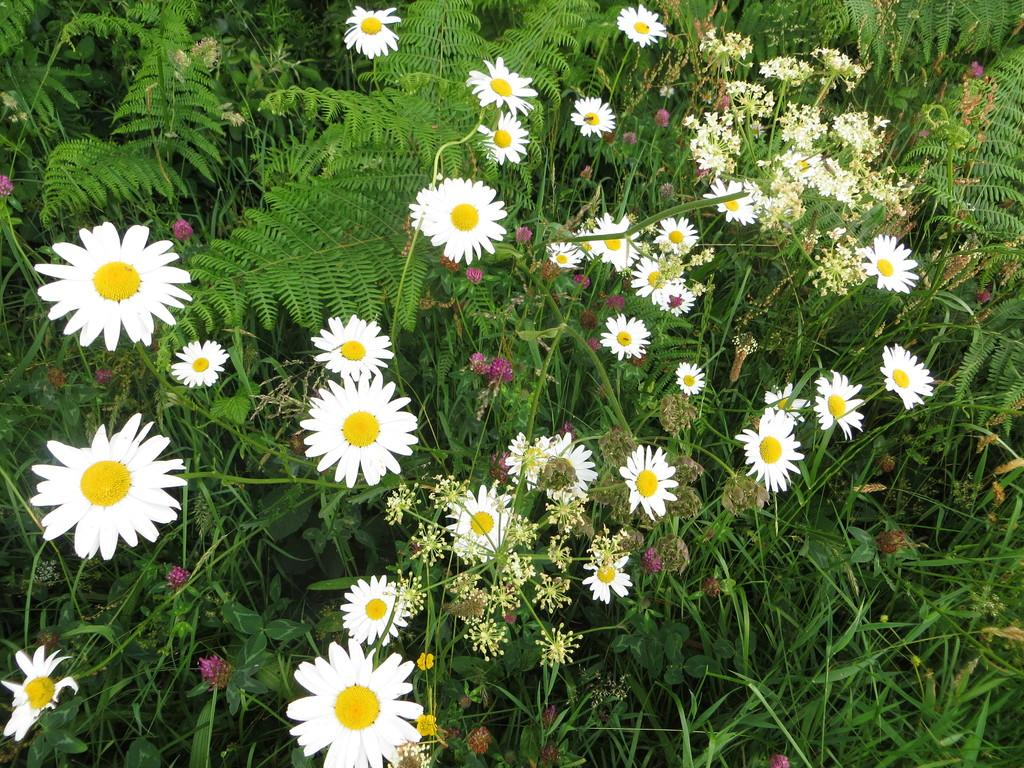What type of vegetation can be seen in the image? There are plants and flowers in the image. What is the ground covered with in the image? There is grass in the image. What song is your mom teaching you in the image? There is no reference to a song or your mom in the image, so it's not possible to answer that question. 